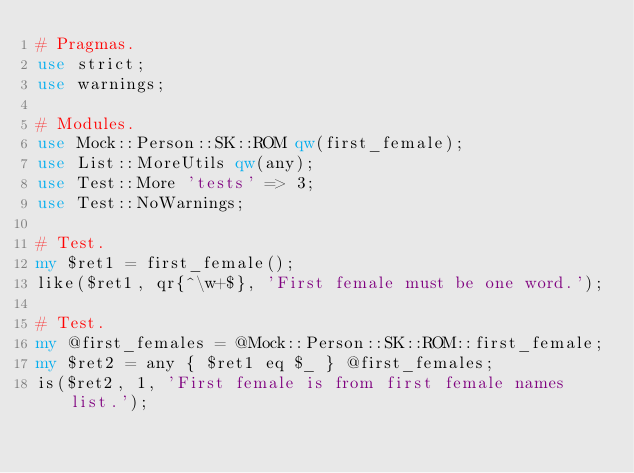<code> <loc_0><loc_0><loc_500><loc_500><_Perl_># Pragmas.
use strict;
use warnings;

# Modules.
use Mock::Person::SK::ROM qw(first_female);
use List::MoreUtils qw(any);
use Test::More 'tests' => 3;
use Test::NoWarnings;

# Test.
my $ret1 = first_female();
like($ret1, qr{^\w+$}, 'First female must be one word.');

# Test.
my @first_females = @Mock::Person::SK::ROM::first_female;
my $ret2 = any { $ret1 eq $_ } @first_females;
is($ret2, 1, 'First female is from first female names list.');
</code> 